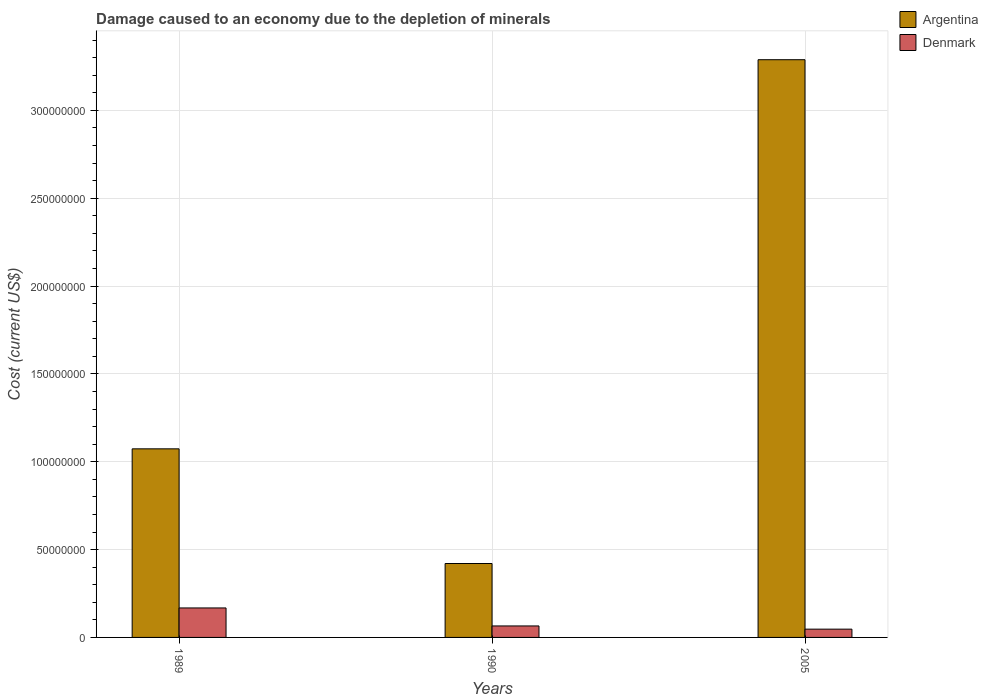How many different coloured bars are there?
Your response must be concise. 2. How many groups of bars are there?
Keep it short and to the point. 3. Are the number of bars per tick equal to the number of legend labels?
Your response must be concise. Yes. How many bars are there on the 2nd tick from the left?
Your response must be concise. 2. How many bars are there on the 3rd tick from the right?
Provide a succinct answer. 2. What is the label of the 2nd group of bars from the left?
Your response must be concise. 1990. What is the cost of damage caused due to the depletion of minerals in Argentina in 2005?
Keep it short and to the point. 3.29e+08. Across all years, what is the maximum cost of damage caused due to the depletion of minerals in Argentina?
Offer a very short reply. 3.29e+08. Across all years, what is the minimum cost of damage caused due to the depletion of minerals in Denmark?
Provide a short and direct response. 4.71e+06. What is the total cost of damage caused due to the depletion of minerals in Denmark in the graph?
Give a very brief answer. 2.80e+07. What is the difference between the cost of damage caused due to the depletion of minerals in Argentina in 1990 and that in 2005?
Provide a short and direct response. -2.87e+08. What is the difference between the cost of damage caused due to the depletion of minerals in Denmark in 1989 and the cost of damage caused due to the depletion of minerals in Argentina in 1990?
Offer a very short reply. -2.53e+07. What is the average cost of damage caused due to the depletion of minerals in Denmark per year?
Your response must be concise. 9.34e+06. In the year 1990, what is the difference between the cost of damage caused due to the depletion of minerals in Argentina and cost of damage caused due to the depletion of minerals in Denmark?
Your answer should be compact. 3.55e+07. In how many years, is the cost of damage caused due to the depletion of minerals in Argentina greater than 40000000 US$?
Your response must be concise. 3. What is the ratio of the cost of damage caused due to the depletion of minerals in Argentina in 1990 to that in 2005?
Your answer should be compact. 0.13. What is the difference between the highest and the second highest cost of damage caused due to the depletion of minerals in Argentina?
Your response must be concise. 2.21e+08. What is the difference between the highest and the lowest cost of damage caused due to the depletion of minerals in Denmark?
Offer a very short reply. 1.21e+07. In how many years, is the cost of damage caused due to the depletion of minerals in Denmark greater than the average cost of damage caused due to the depletion of minerals in Denmark taken over all years?
Your response must be concise. 1. Is the sum of the cost of damage caused due to the depletion of minerals in Argentina in 1990 and 2005 greater than the maximum cost of damage caused due to the depletion of minerals in Denmark across all years?
Keep it short and to the point. Yes. What does the 1st bar from the right in 1989 represents?
Your answer should be very brief. Denmark. What is the title of the graph?
Your answer should be compact. Damage caused to an economy due to the depletion of minerals. What is the label or title of the X-axis?
Keep it short and to the point. Years. What is the label or title of the Y-axis?
Your response must be concise. Cost (current US$). What is the Cost (current US$) of Argentina in 1989?
Offer a terse response. 1.07e+08. What is the Cost (current US$) of Denmark in 1989?
Offer a terse response. 1.68e+07. What is the Cost (current US$) in Argentina in 1990?
Provide a succinct answer. 4.21e+07. What is the Cost (current US$) of Denmark in 1990?
Your response must be concise. 6.54e+06. What is the Cost (current US$) of Argentina in 2005?
Your answer should be compact. 3.29e+08. What is the Cost (current US$) of Denmark in 2005?
Make the answer very short. 4.71e+06. Across all years, what is the maximum Cost (current US$) of Argentina?
Your response must be concise. 3.29e+08. Across all years, what is the maximum Cost (current US$) in Denmark?
Provide a short and direct response. 1.68e+07. Across all years, what is the minimum Cost (current US$) in Argentina?
Keep it short and to the point. 4.21e+07. Across all years, what is the minimum Cost (current US$) of Denmark?
Give a very brief answer. 4.71e+06. What is the total Cost (current US$) in Argentina in the graph?
Make the answer very short. 4.78e+08. What is the total Cost (current US$) in Denmark in the graph?
Give a very brief answer. 2.80e+07. What is the difference between the Cost (current US$) in Argentina in 1989 and that in 1990?
Your answer should be very brief. 6.53e+07. What is the difference between the Cost (current US$) in Denmark in 1989 and that in 1990?
Provide a succinct answer. 1.02e+07. What is the difference between the Cost (current US$) of Argentina in 1989 and that in 2005?
Your answer should be very brief. -2.21e+08. What is the difference between the Cost (current US$) in Denmark in 1989 and that in 2005?
Make the answer very short. 1.21e+07. What is the difference between the Cost (current US$) of Argentina in 1990 and that in 2005?
Give a very brief answer. -2.87e+08. What is the difference between the Cost (current US$) in Denmark in 1990 and that in 2005?
Offer a terse response. 1.83e+06. What is the difference between the Cost (current US$) of Argentina in 1989 and the Cost (current US$) of Denmark in 1990?
Provide a short and direct response. 1.01e+08. What is the difference between the Cost (current US$) of Argentina in 1989 and the Cost (current US$) of Denmark in 2005?
Offer a very short reply. 1.03e+08. What is the difference between the Cost (current US$) of Argentina in 1990 and the Cost (current US$) of Denmark in 2005?
Your response must be concise. 3.74e+07. What is the average Cost (current US$) in Argentina per year?
Give a very brief answer. 1.59e+08. What is the average Cost (current US$) of Denmark per year?
Keep it short and to the point. 9.34e+06. In the year 1989, what is the difference between the Cost (current US$) in Argentina and Cost (current US$) in Denmark?
Provide a short and direct response. 9.06e+07. In the year 1990, what is the difference between the Cost (current US$) of Argentina and Cost (current US$) of Denmark?
Your response must be concise. 3.55e+07. In the year 2005, what is the difference between the Cost (current US$) of Argentina and Cost (current US$) of Denmark?
Your answer should be compact. 3.24e+08. What is the ratio of the Cost (current US$) in Argentina in 1989 to that in 1990?
Provide a short and direct response. 2.55. What is the ratio of the Cost (current US$) of Denmark in 1989 to that in 1990?
Keep it short and to the point. 2.57. What is the ratio of the Cost (current US$) in Argentina in 1989 to that in 2005?
Give a very brief answer. 0.33. What is the ratio of the Cost (current US$) of Denmark in 1989 to that in 2005?
Provide a short and direct response. 3.56. What is the ratio of the Cost (current US$) of Argentina in 1990 to that in 2005?
Your answer should be very brief. 0.13. What is the ratio of the Cost (current US$) of Denmark in 1990 to that in 2005?
Provide a succinct answer. 1.39. What is the difference between the highest and the second highest Cost (current US$) of Argentina?
Give a very brief answer. 2.21e+08. What is the difference between the highest and the second highest Cost (current US$) in Denmark?
Your answer should be very brief. 1.02e+07. What is the difference between the highest and the lowest Cost (current US$) of Argentina?
Provide a succinct answer. 2.87e+08. What is the difference between the highest and the lowest Cost (current US$) of Denmark?
Provide a short and direct response. 1.21e+07. 